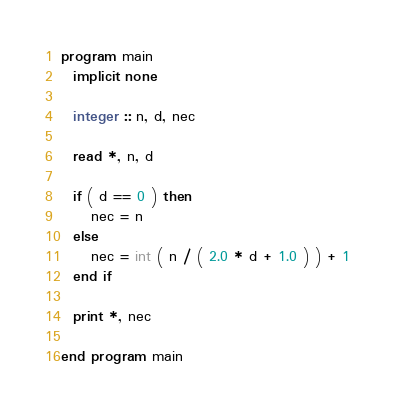<code> <loc_0><loc_0><loc_500><loc_500><_FORTRAN_>program main
  implicit none

  integer :: n, d, nec

  read *, n, d
  
  if ( d == 0 ) then
     nec = n
  else
     nec = int ( n / ( 2.0 * d + 1.0 ) ) + 1
  end if
  
  print *, nec

end program main

</code> 